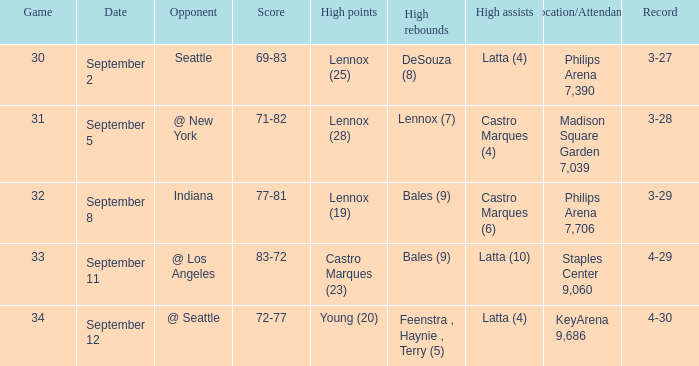What were the high rebounds on september 11? Bales (9). 